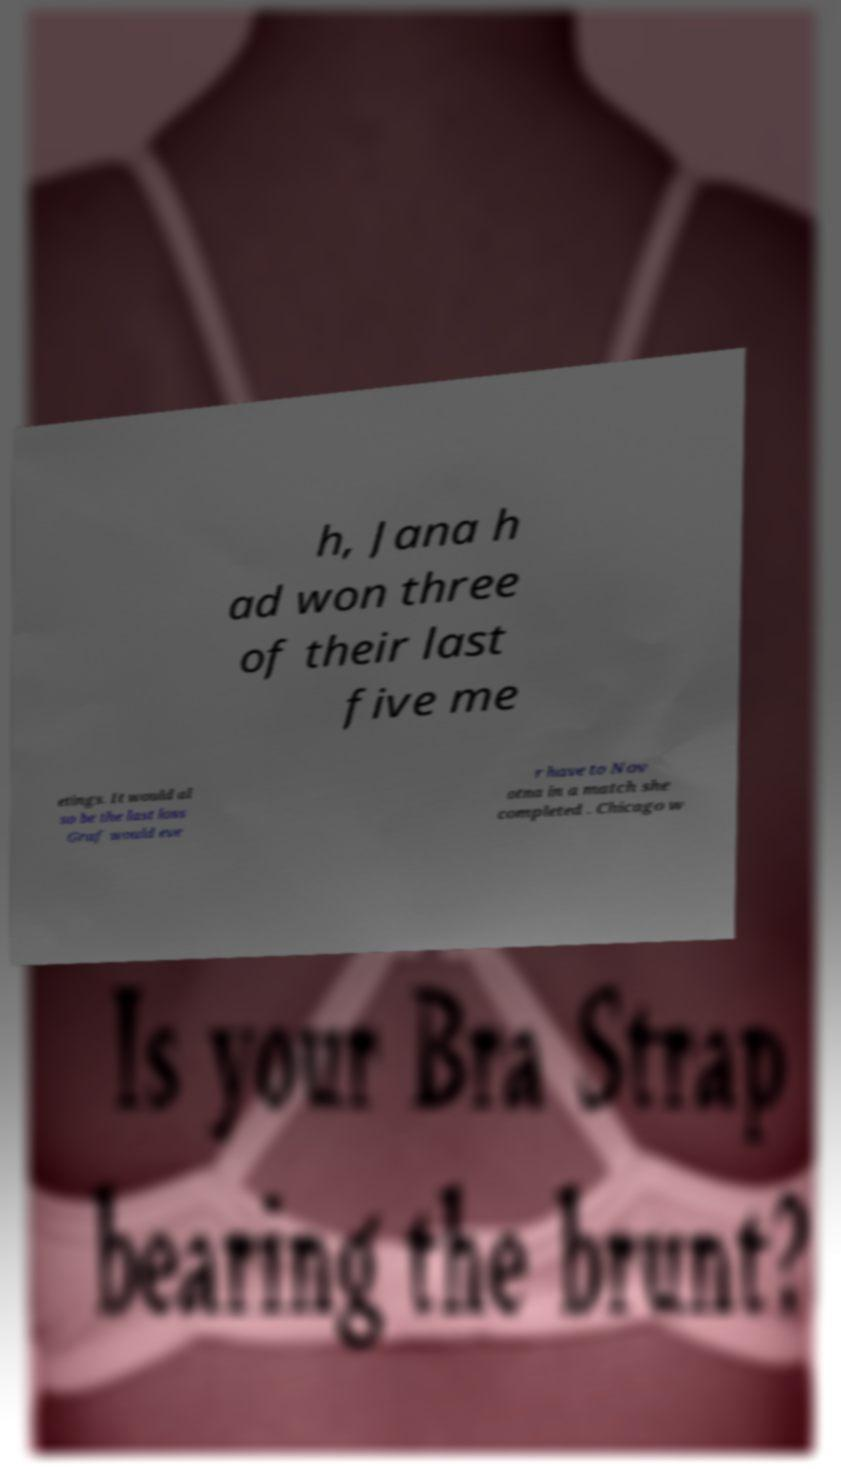Could you extract and type out the text from this image? h, Jana h ad won three of their last five me etings. It would al so be the last loss Graf would eve r have to Nov otna in a match she completed . Chicago w 